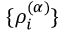<formula> <loc_0><loc_0><loc_500><loc_500>\{ \rho _ { i } ^ { ( \alpha ) } \}</formula> 